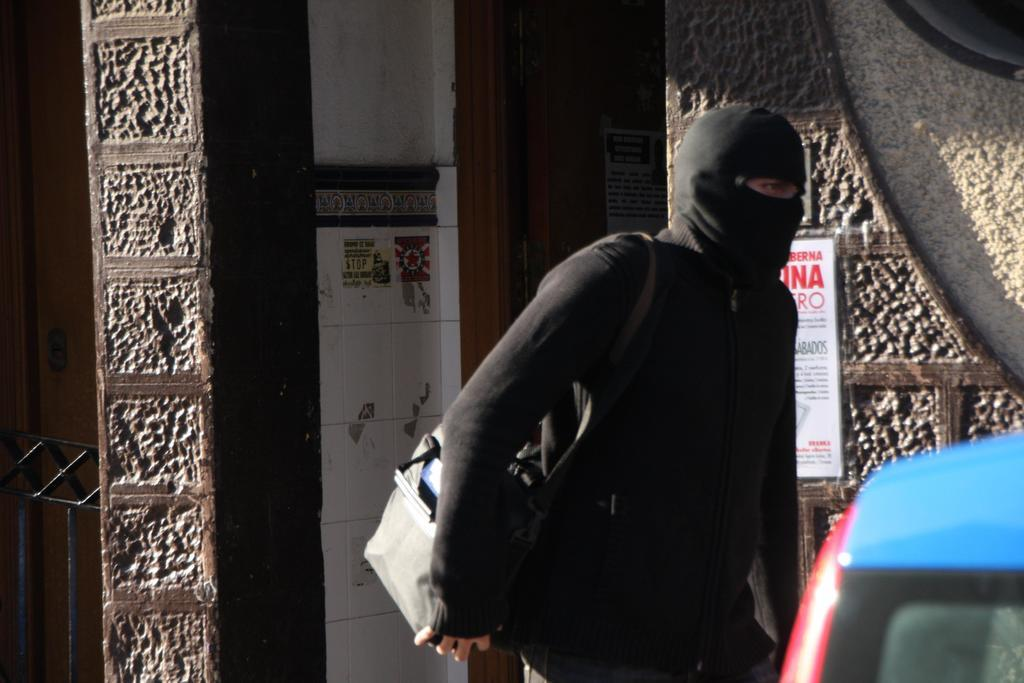Who is the main subject in the image? There is a man in the image. What is the man doing in the image? The man is walking on the road. What is the man wearing in the image? The man is wearing a black dress. What is the man carrying in the image? The man has a bag on his shoulder. What can be seen in the background of the image? There is a wall in the background of the image. What is the name of the agreement the man signed in the image? There is no agreement or signing event depicted in the image; the man is simply walking on the road. How does the man's digestion system work in the image? There is no information about the man's digestion system in the image; it only shows him walking on the road. 